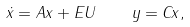Convert formula to latex. <formula><loc_0><loc_0><loc_500><loc_500>\dot { x } = A x + E U \quad y = C x ,</formula> 